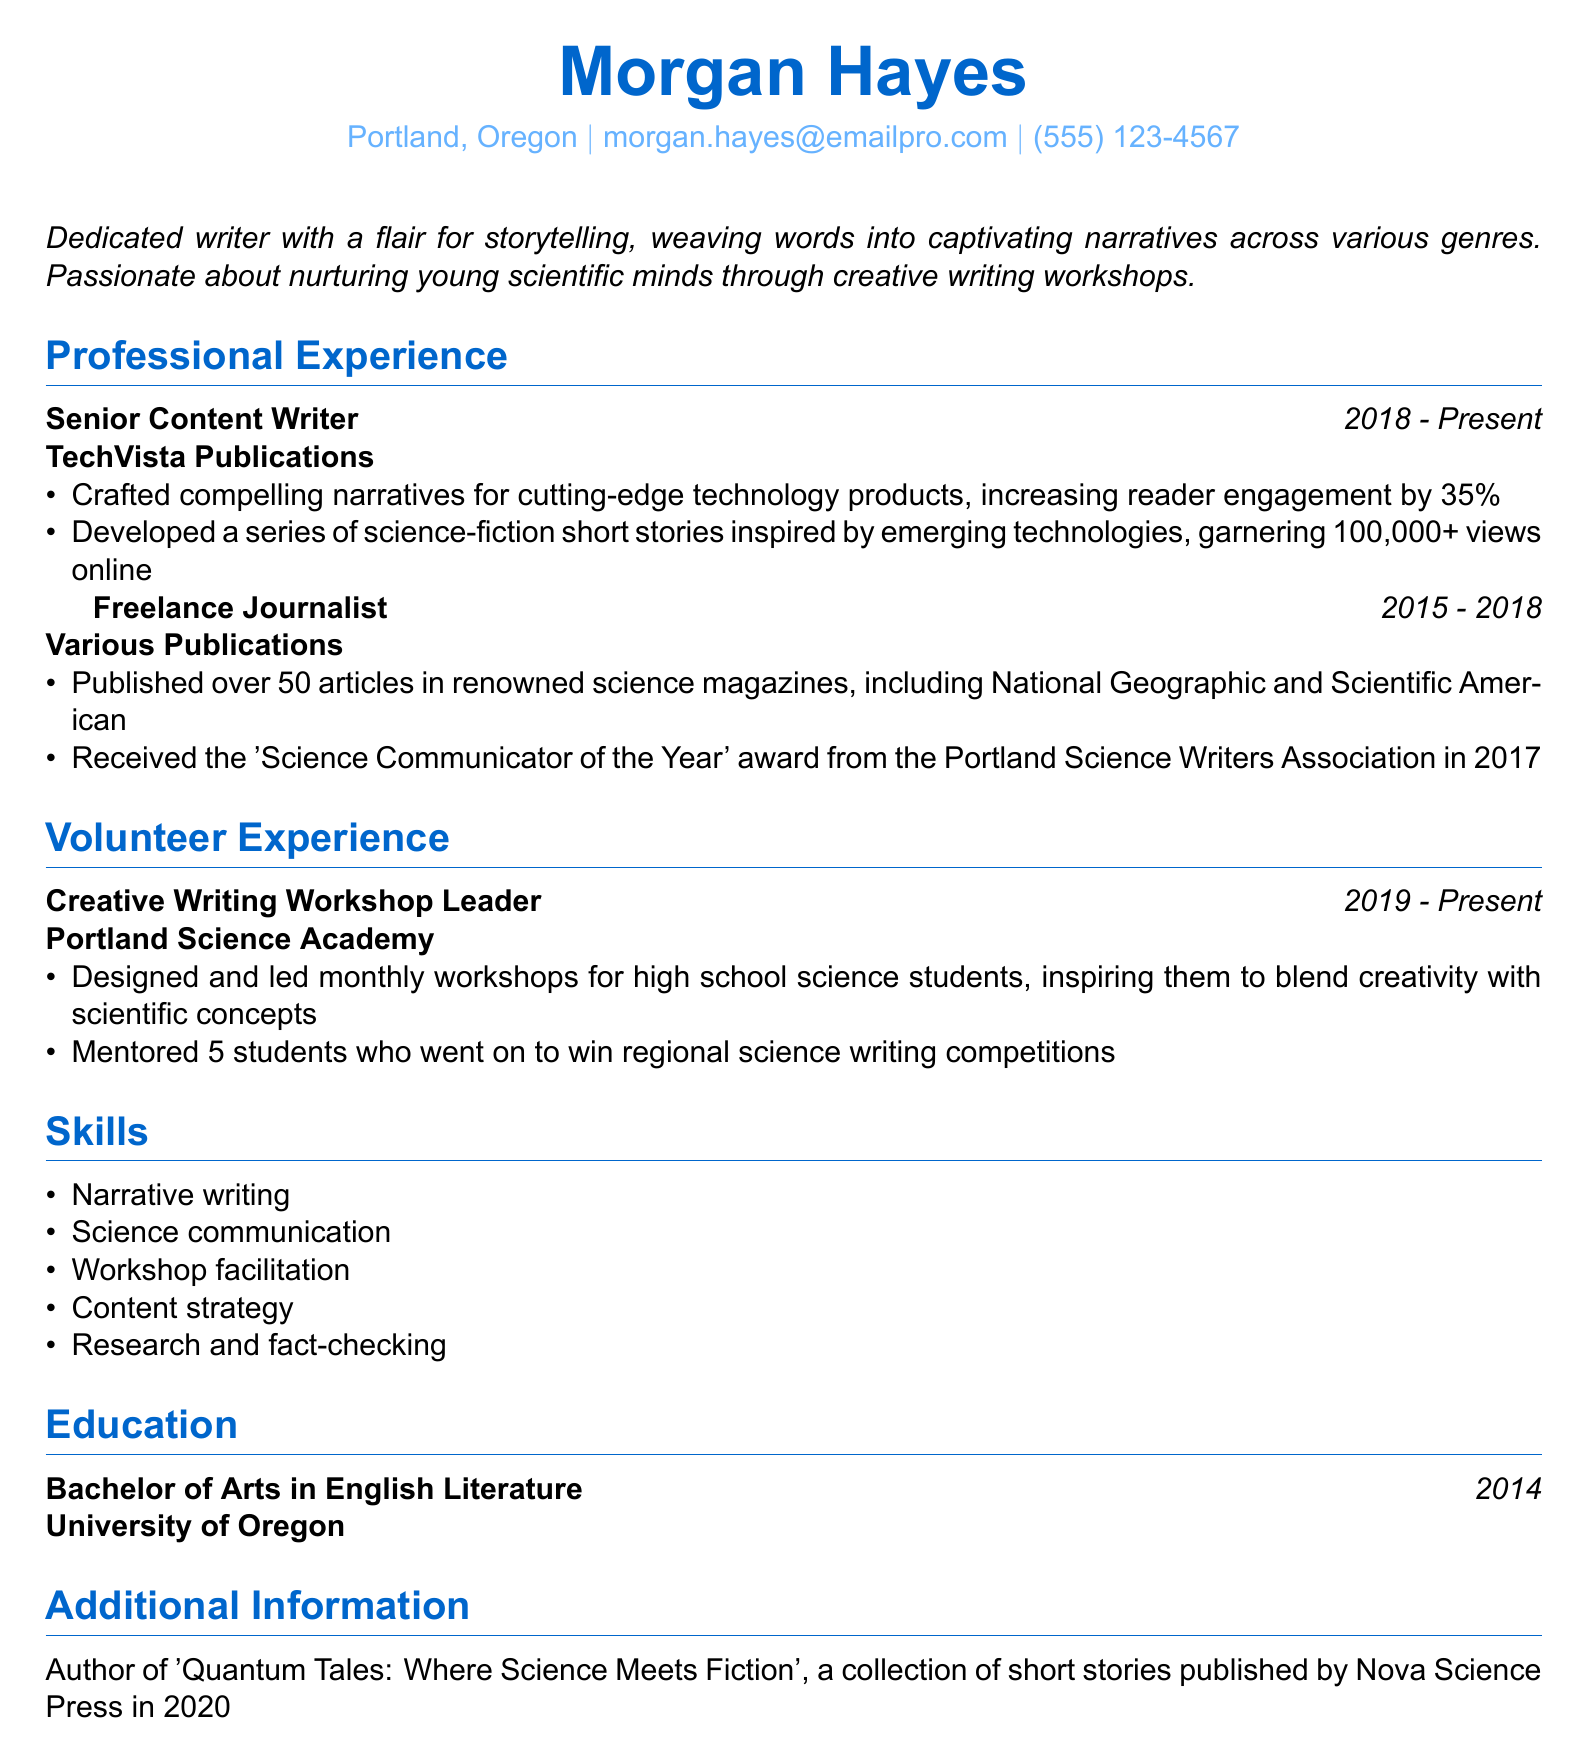What is the name of the individual? The document lists the individual's name prominently at the top, which is Morgan Hayes.
Answer: Morgan Hayes What is the email address provided? The document explicitly states the email address under personal information, which is morgan.hayes@emailpro.com.
Answer: morgan.hayes@emailpro.com How long has Morgan Hayes been a Senior Content Writer? This role duration is specified in the document as starting in 2018 and continuing to the present, indicating a total experience of approximately 5 years.
Answer: 5 years Which award did Morgan Hayes receive in 2017? The document specifies that Morgan Hayes received the 'Science Communicator of the Year' award from the Portland Science Writers Association in that year.
Answer: Science Communicator of the Year What type of workshops does Morgan lead? The document mentions that the workshops are focused on creative writing for high school science students.
Answer: Creative writing How many students did Morgan mentor who won competitions? The document states that Morgan mentored 5 students who achieved this success in regional science writing competitions.
Answer: 5 students When did Morgan graduate and from which institution? The document specifies that Morgan graduated in 2014 with a degree from the University of Oregon.
Answer: 2014, University of Oregon What is the title of Morgan's published collection of short stories? The document notes that the title of the collection is 'Quantum Tales: Where Science Meets Fiction'.
Answer: Quantum Tales: Where Science Meets Fiction 